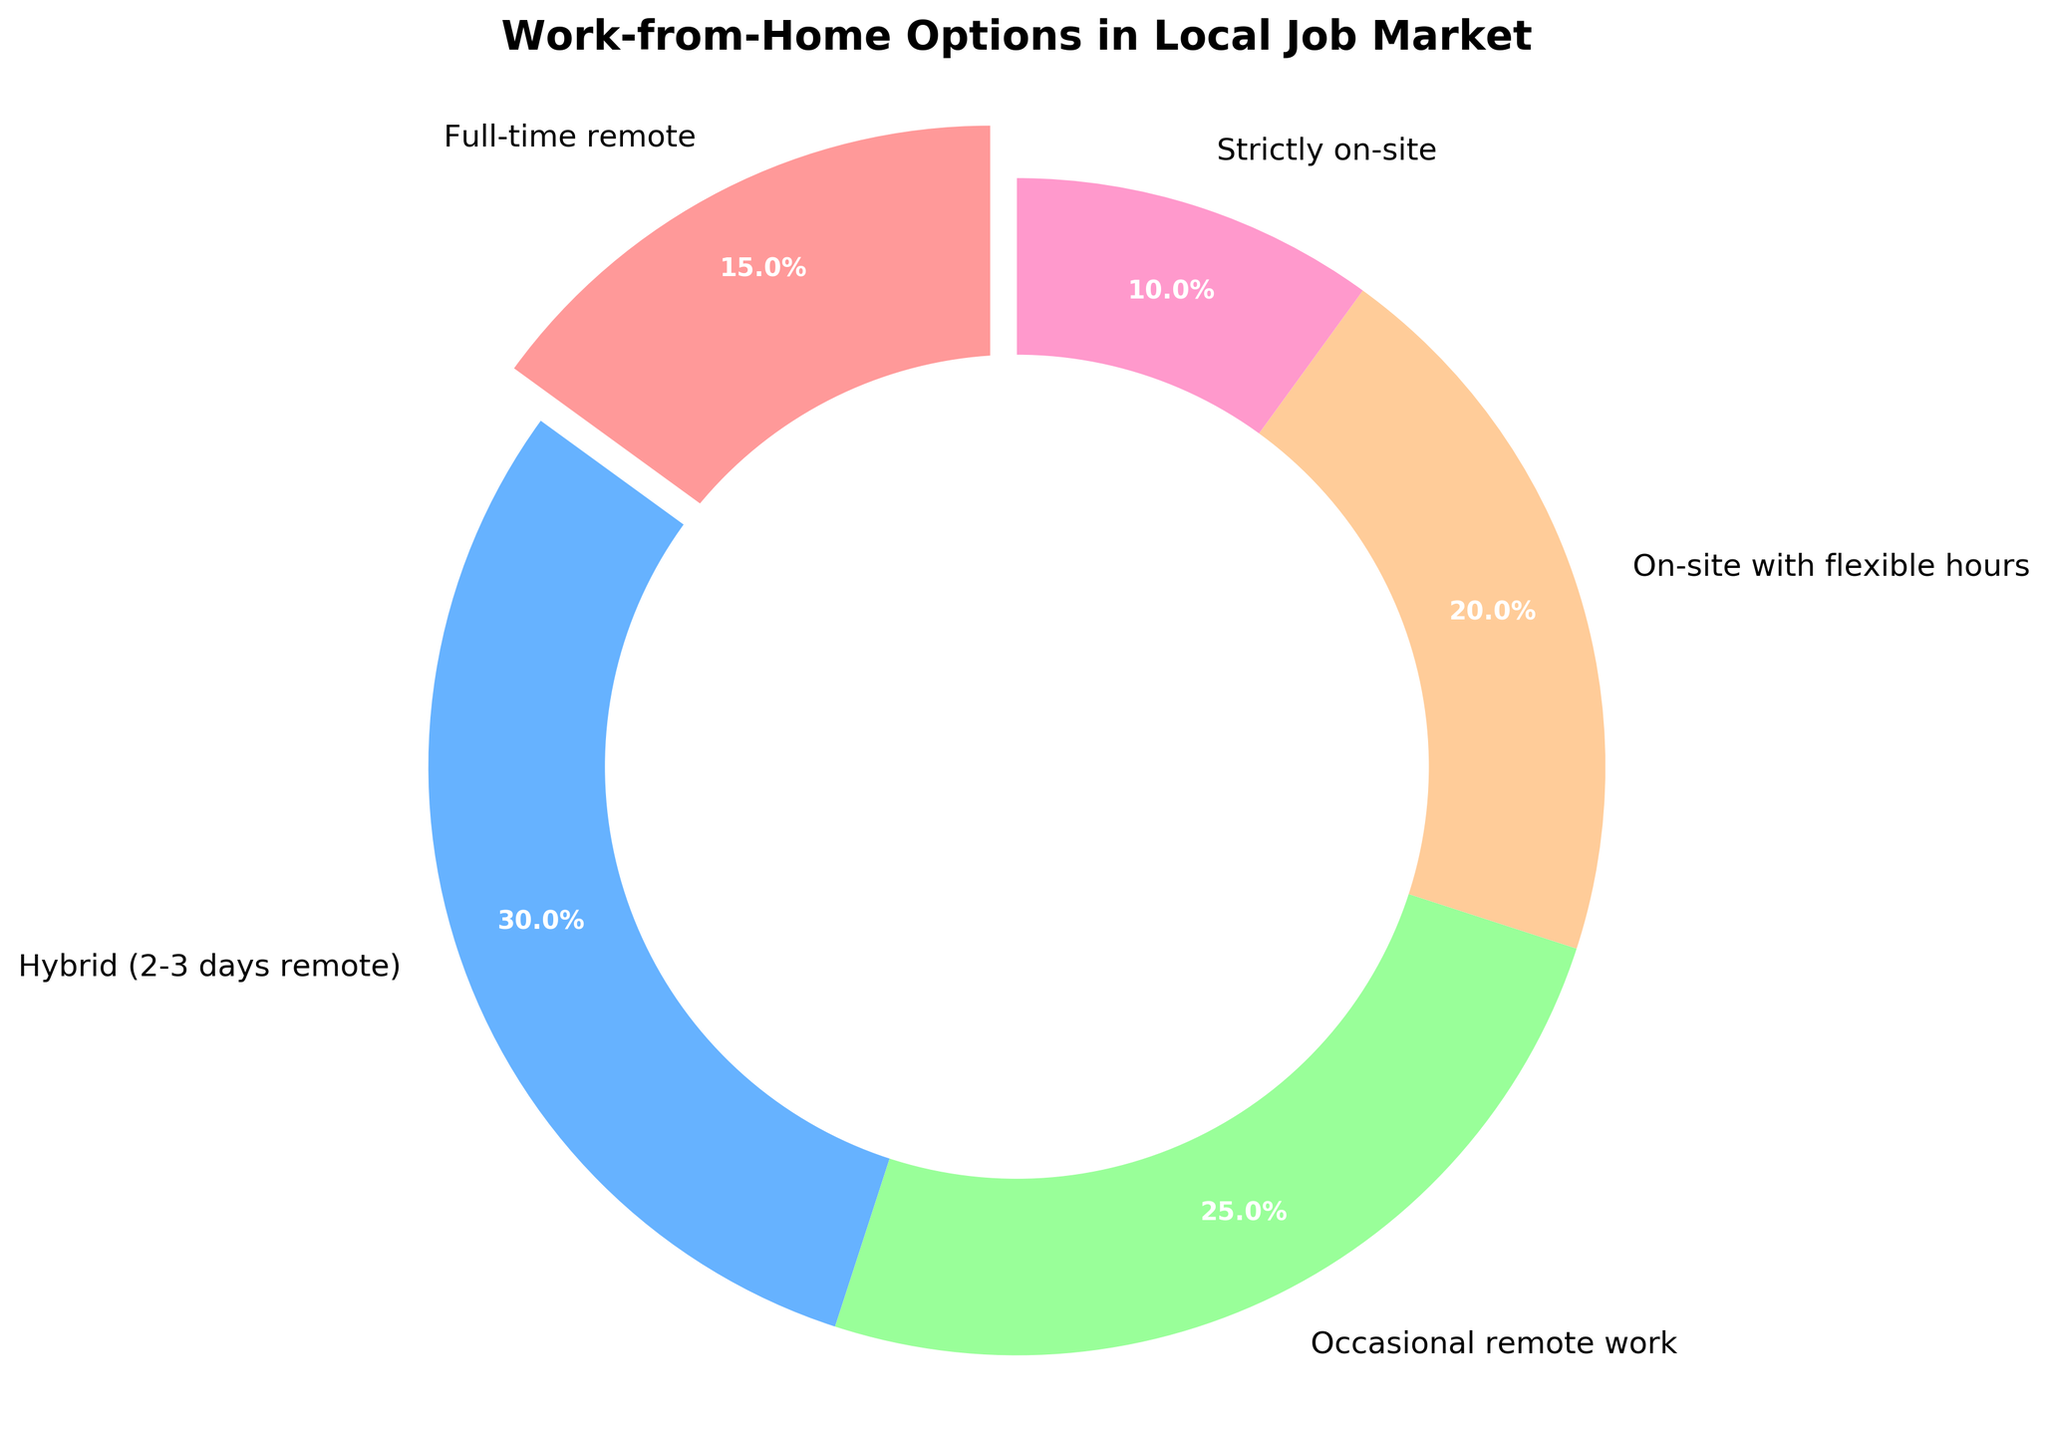what category has the highest percentage of companies offering work-from-home options? To determine which category has the highest percentage, we need to look at the values in the pie chart. The category with the highest number is "Hybrid (2-3 days remote)" with 30%.
Answer: Hybrid (2-3 days remote) what is the percentage difference between full-time remote and strictly on-site options? Subtract the percentage of strictly on-site (10%) from the percentage of full-time remote (15%): 15% - 10% = 5%.
Answer: 5% what percentage of companies offer some form of remote work (full-time, hybrid, occasional)? To find the combined percentage of companies offering full-time remote, hybrid, and occasional remote work, add their individual percentages: 15% (full-time remote) + 30% (hybrid) + 25% (occasional) = 70%.
Answer: 70% which category has the smallest proportion of work-from-home options? From the chart, we see the values for each category. The smallest proportion is for "Strictly on-site" with 10%.
Answer: Strictly on-site combine the percentages of occasional remote work and on-site with flexible hours. What fraction of the total job market does this represent? Adding the percentages of occasional remote work (25%) and on-site with flexible hours (20%) gives us 45%. 45% of the total job market offers these options.
Answer: 45% compare the proportions of full-time remote and on-site with flexible hours. Which is greater, and by how much? The percentage for on-site with flexible hours (20%) is greater than for full-time remote (15%). The difference is 20% - 15% = 5%.
Answer: On-site with flexible hours, 5% what proportion of companies offer either hybrid or strictly on-site options? Adding the percentage for hybrid (30%) and strictly on-site (10%) gives us 40%. Therefore, 40% of companies offer these options.
Answer: 40% what color is used to represent hybrid (2-3 days remote) work in the pie chart? Observing the colors in the pie chart, hybrid (2-3 days remote) is represented by the blue section.
Answer: Blue 